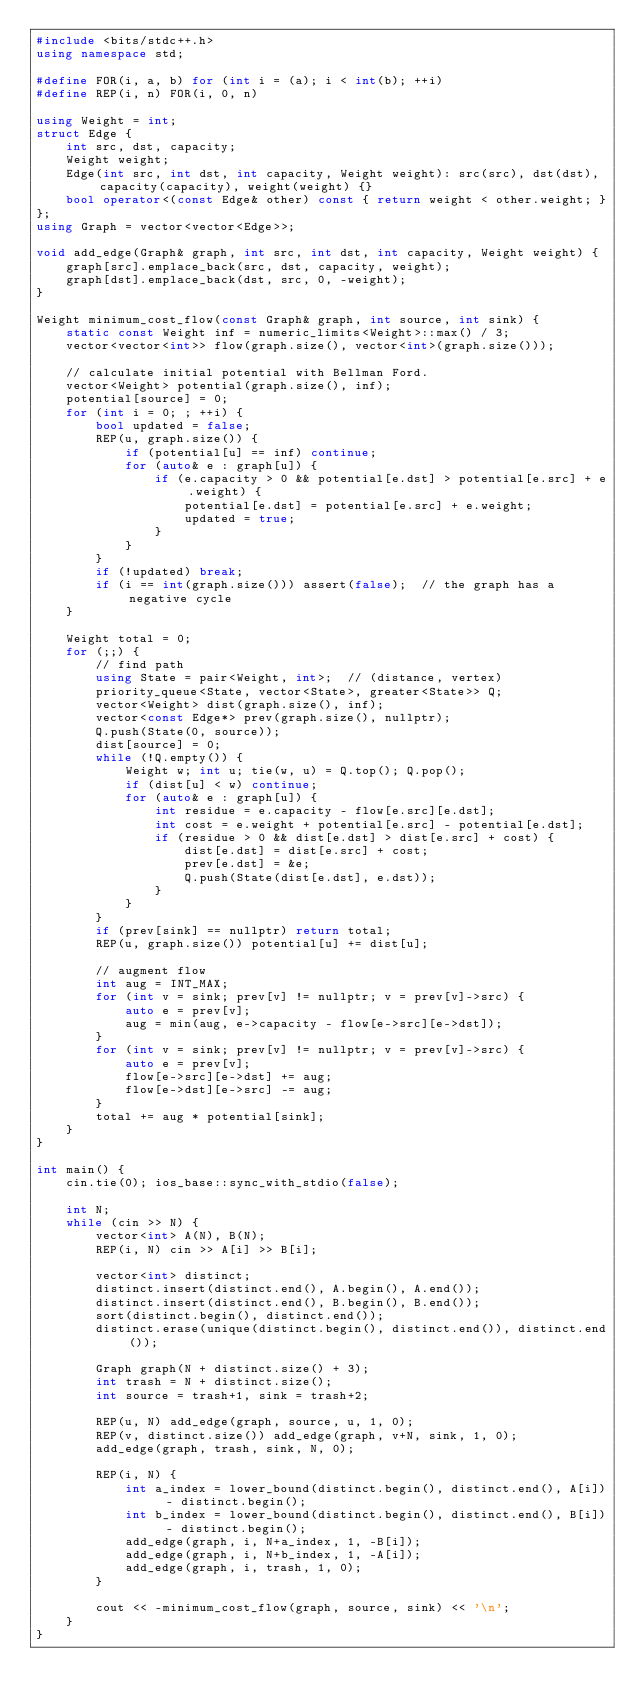Convert code to text. <code><loc_0><loc_0><loc_500><loc_500><_C++_>#include <bits/stdc++.h>
using namespace std;

#define FOR(i, a, b) for (int i = (a); i < int(b); ++i)
#define REP(i, n) FOR(i, 0, n)

using Weight = int;
struct Edge {
    int src, dst, capacity;
    Weight weight;
    Edge(int src, int dst, int capacity, Weight weight): src(src), dst(dst), capacity(capacity), weight(weight) {}
    bool operator<(const Edge& other) const { return weight < other.weight; }
};
using Graph = vector<vector<Edge>>;

void add_edge(Graph& graph, int src, int dst, int capacity, Weight weight) {
    graph[src].emplace_back(src, dst, capacity, weight);
    graph[dst].emplace_back(dst, src, 0, -weight);
}

Weight minimum_cost_flow(const Graph& graph, int source, int sink) {
    static const Weight inf = numeric_limits<Weight>::max() / 3;
    vector<vector<int>> flow(graph.size(), vector<int>(graph.size()));

    // calculate initial potential with Bellman Ford.
    vector<Weight> potential(graph.size(), inf);
    potential[source] = 0;
    for (int i = 0; ; ++i) {
        bool updated = false;
        REP(u, graph.size()) {
            if (potential[u] == inf) continue;
            for (auto& e : graph[u]) {
                if (e.capacity > 0 && potential[e.dst] > potential[e.src] + e.weight) {
                    potential[e.dst] = potential[e.src] + e.weight;
                    updated = true;
                }
            }
        }
        if (!updated) break;
        if (i == int(graph.size())) assert(false);  // the graph has a negative cycle
    }

    Weight total = 0;
    for (;;) {
        // find path
        using State = pair<Weight, int>;  // (distance, vertex)
        priority_queue<State, vector<State>, greater<State>> Q;
        vector<Weight> dist(graph.size(), inf);
        vector<const Edge*> prev(graph.size(), nullptr);
        Q.push(State(0, source));
        dist[source] = 0;
        while (!Q.empty()) {
            Weight w; int u; tie(w, u) = Q.top(); Q.pop();
            if (dist[u] < w) continue;
            for (auto& e : graph[u]) {
                int residue = e.capacity - flow[e.src][e.dst];
                int cost = e.weight + potential[e.src] - potential[e.dst];
                if (residue > 0 && dist[e.dst] > dist[e.src] + cost) {
                    dist[e.dst] = dist[e.src] + cost;
                    prev[e.dst] = &e;
                    Q.push(State(dist[e.dst], e.dst));
                }
            }
        }
        if (prev[sink] == nullptr) return total;
        REP(u, graph.size()) potential[u] += dist[u];

        // augment flow
        int aug = INT_MAX;
        for (int v = sink; prev[v] != nullptr; v = prev[v]->src) {
            auto e = prev[v];
            aug = min(aug, e->capacity - flow[e->src][e->dst]);
        }
        for (int v = sink; prev[v] != nullptr; v = prev[v]->src) {
            auto e = prev[v];
            flow[e->src][e->dst] += aug;
            flow[e->dst][e->src] -= aug;
        }
        total += aug * potential[sink];
    }
}

int main() {
    cin.tie(0); ios_base::sync_with_stdio(false);

    int N;
    while (cin >> N) {
        vector<int> A(N), B(N);
        REP(i, N) cin >> A[i] >> B[i];

        vector<int> distinct;
        distinct.insert(distinct.end(), A.begin(), A.end());
        distinct.insert(distinct.end(), B.begin(), B.end());
        sort(distinct.begin(), distinct.end());
        distinct.erase(unique(distinct.begin(), distinct.end()), distinct.end());

        Graph graph(N + distinct.size() + 3);
        int trash = N + distinct.size();
        int source = trash+1, sink = trash+2;

        REP(u, N) add_edge(graph, source, u, 1, 0);
        REP(v, distinct.size()) add_edge(graph, v+N, sink, 1, 0);
        add_edge(graph, trash, sink, N, 0);

        REP(i, N) {
            int a_index = lower_bound(distinct.begin(), distinct.end(), A[i]) - distinct.begin();
            int b_index = lower_bound(distinct.begin(), distinct.end(), B[i]) - distinct.begin();
            add_edge(graph, i, N+a_index, 1, -B[i]);
            add_edge(graph, i, N+b_index, 1, -A[i]);
            add_edge(graph, i, trash, 1, 0);
        }

        cout << -minimum_cost_flow(graph, source, sink) << '\n';
    }
}</code> 